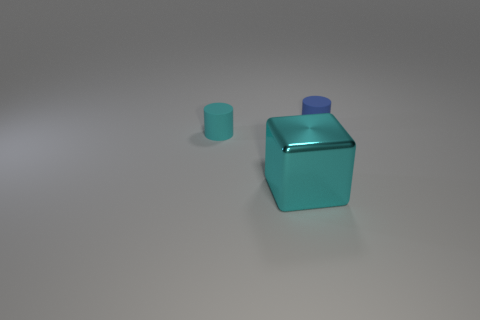Are there any other things that have the same material as the block?
Keep it short and to the point. No. There is a object that is the same size as the blue cylinder; what is it made of?
Your answer should be very brief. Rubber. What number of other things are there of the same material as the tiny blue cylinder
Offer a terse response. 1. The large cyan metallic object that is in front of the cylinder that is to the right of the metal cube is what shape?
Offer a terse response. Cube. What number of objects are small red shiny blocks or small matte cylinders behind the small cyan cylinder?
Your answer should be very brief. 1. What number of cyan objects are either metallic blocks or small cylinders?
Make the answer very short. 2. Is there a matte cylinder right of the tiny blue rubber cylinder that is on the right side of the matte thing to the left of the large shiny object?
Your answer should be compact. No. Are there any other things that have the same size as the blue thing?
Your answer should be compact. Yes. What is the color of the cylinder behind the matte cylinder that is to the left of the small blue matte thing?
Offer a terse response. Blue. What number of big objects are either metallic objects or red metallic blocks?
Offer a terse response. 1. 